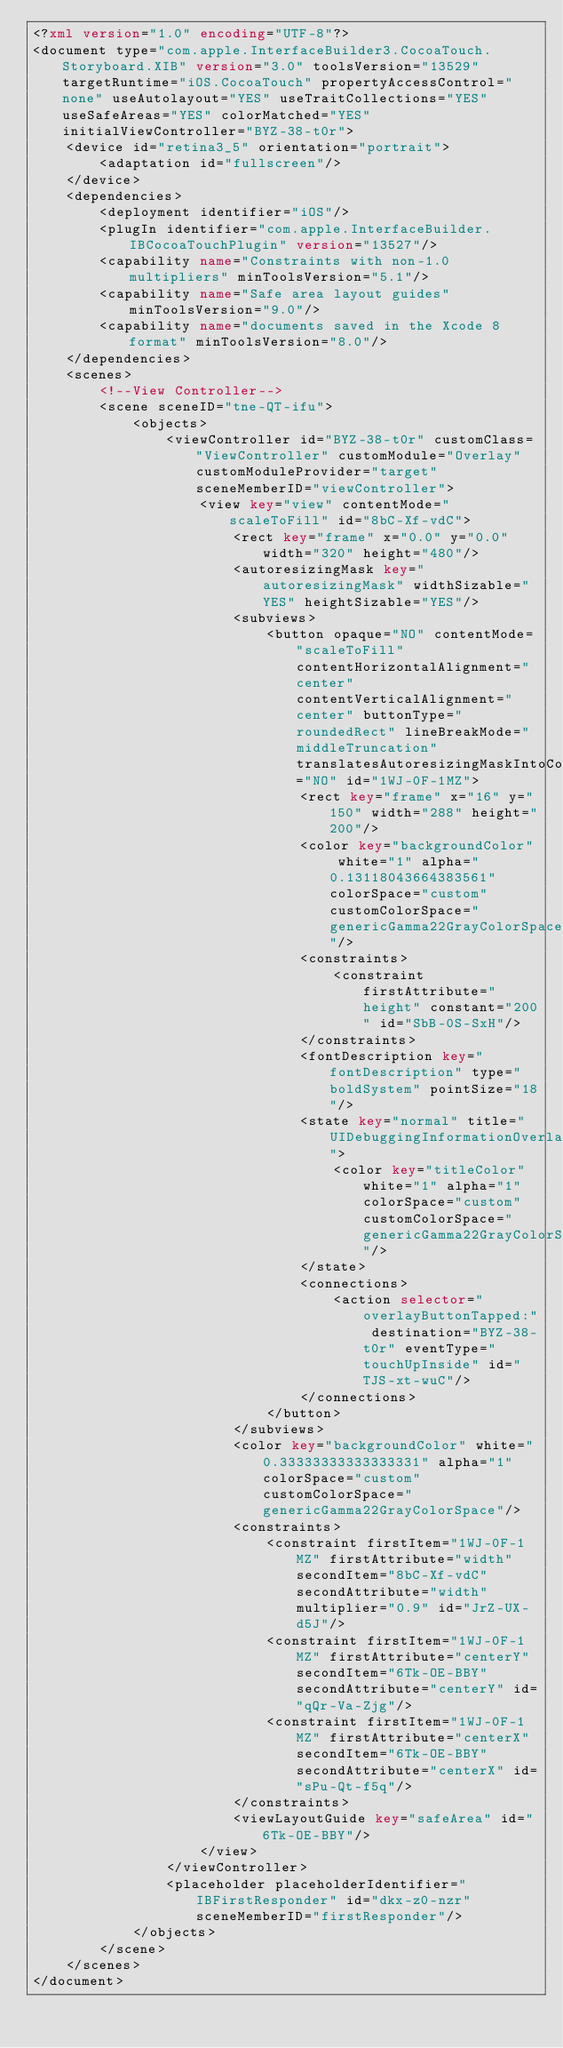Convert code to text. <code><loc_0><loc_0><loc_500><loc_500><_XML_><?xml version="1.0" encoding="UTF-8"?>
<document type="com.apple.InterfaceBuilder3.CocoaTouch.Storyboard.XIB" version="3.0" toolsVersion="13529" targetRuntime="iOS.CocoaTouch" propertyAccessControl="none" useAutolayout="YES" useTraitCollections="YES" useSafeAreas="YES" colorMatched="YES" initialViewController="BYZ-38-t0r">
    <device id="retina3_5" orientation="portrait">
        <adaptation id="fullscreen"/>
    </device>
    <dependencies>
        <deployment identifier="iOS"/>
        <plugIn identifier="com.apple.InterfaceBuilder.IBCocoaTouchPlugin" version="13527"/>
        <capability name="Constraints with non-1.0 multipliers" minToolsVersion="5.1"/>
        <capability name="Safe area layout guides" minToolsVersion="9.0"/>
        <capability name="documents saved in the Xcode 8 format" minToolsVersion="8.0"/>
    </dependencies>
    <scenes>
        <!--View Controller-->
        <scene sceneID="tne-QT-ifu">
            <objects>
                <viewController id="BYZ-38-t0r" customClass="ViewController" customModule="Overlay" customModuleProvider="target" sceneMemberID="viewController">
                    <view key="view" contentMode="scaleToFill" id="8bC-Xf-vdC">
                        <rect key="frame" x="0.0" y="0.0" width="320" height="480"/>
                        <autoresizingMask key="autoresizingMask" widthSizable="YES" heightSizable="YES"/>
                        <subviews>
                            <button opaque="NO" contentMode="scaleToFill" contentHorizontalAlignment="center" contentVerticalAlignment="center" buttonType="roundedRect" lineBreakMode="middleTruncation" translatesAutoresizingMaskIntoConstraints="NO" id="1WJ-0F-1MZ">
                                <rect key="frame" x="16" y="150" width="288" height="200"/>
                                <color key="backgroundColor" white="1" alpha="0.13118043664383561" colorSpace="custom" customColorSpace="genericGamma22GrayColorSpace"/>
                                <constraints>
                                    <constraint firstAttribute="height" constant="200" id="SbB-0S-SxH"/>
                                </constraints>
                                <fontDescription key="fontDescription" type="boldSystem" pointSize="18"/>
                                <state key="normal" title="UIDebuggingInformationOverlay">
                                    <color key="titleColor" white="1" alpha="1" colorSpace="custom" customColorSpace="genericGamma22GrayColorSpace"/>
                                </state>
                                <connections>
                                    <action selector="overlayButtonTapped:" destination="BYZ-38-t0r" eventType="touchUpInside" id="TJS-xt-wuC"/>
                                </connections>
                            </button>
                        </subviews>
                        <color key="backgroundColor" white="0.33333333333333331" alpha="1" colorSpace="custom" customColorSpace="genericGamma22GrayColorSpace"/>
                        <constraints>
                            <constraint firstItem="1WJ-0F-1MZ" firstAttribute="width" secondItem="8bC-Xf-vdC" secondAttribute="width" multiplier="0.9" id="JrZ-UX-d5J"/>
                            <constraint firstItem="1WJ-0F-1MZ" firstAttribute="centerY" secondItem="6Tk-OE-BBY" secondAttribute="centerY" id="qQr-Va-Zjg"/>
                            <constraint firstItem="1WJ-0F-1MZ" firstAttribute="centerX" secondItem="6Tk-OE-BBY" secondAttribute="centerX" id="sPu-Qt-f5q"/>
                        </constraints>
                        <viewLayoutGuide key="safeArea" id="6Tk-OE-BBY"/>
                    </view>
                </viewController>
                <placeholder placeholderIdentifier="IBFirstResponder" id="dkx-z0-nzr" sceneMemberID="firstResponder"/>
            </objects>
        </scene>
    </scenes>
</document>
</code> 